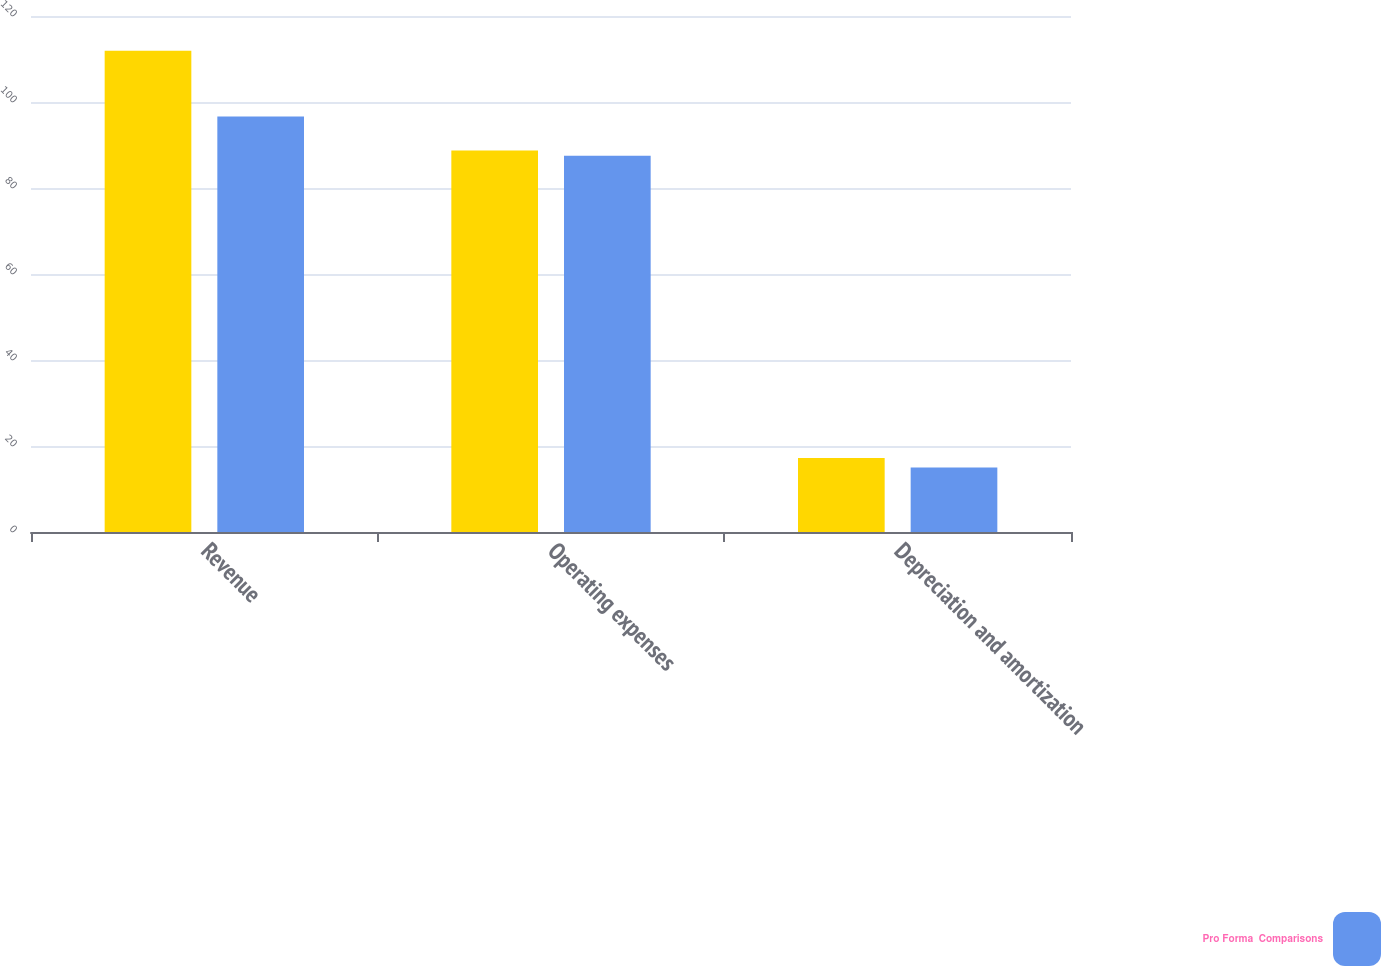Convert chart. <chart><loc_0><loc_0><loc_500><loc_500><stacked_bar_chart><ecel><fcel>Revenue<fcel>Operating expenses<fcel>Depreciation and amortization<nl><fcel>nan<fcel>111.9<fcel>88.7<fcel>17.2<nl><fcel>Pro Forma  Comparisons<fcel>96.6<fcel>87.5<fcel>15<nl></chart> 